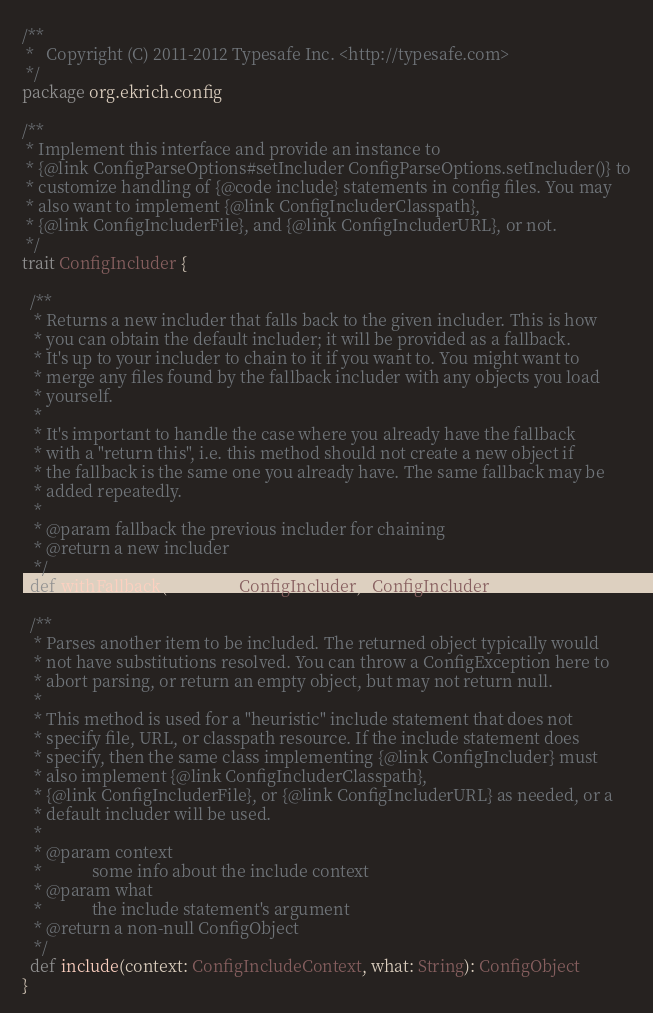<code> <loc_0><loc_0><loc_500><loc_500><_Scala_>/**
 *   Copyright (C) 2011-2012 Typesafe Inc. <http://typesafe.com>
 */
package org.ekrich.config

/**
 * Implement this interface and provide an instance to
 * {@link ConfigParseOptions#setIncluder ConfigParseOptions.setIncluder()} to
 * customize handling of {@code include} statements in config files. You may
 * also want to implement {@link ConfigIncluderClasspath},
 * {@link ConfigIncluderFile}, and {@link ConfigIncluderURL}, or not.
 */
trait ConfigIncluder {

  /**
   * Returns a new includer that falls back to the given includer. This is how
   * you can obtain the default includer; it will be provided as a fallback.
   * It's up to your includer to chain to it if you want to. You might want to
   * merge any files found by the fallback includer with any objects you load
   * yourself.
   *
   * It's important to handle the case where you already have the fallback
   * with a "return this", i.e. this method should not create a new object if
   * the fallback is the same one you already have. The same fallback may be
   * added repeatedly.
   *
   * @param fallback the previous includer for chaining
   * @return a new includer
   */
  def withFallback(fallback: ConfigIncluder): ConfigIncluder

  /**
   * Parses another item to be included. The returned object typically would
   * not have substitutions resolved. You can throw a ConfigException here to
   * abort parsing, or return an empty object, but may not return null.
   *
   * This method is used for a "heuristic" include statement that does not
   * specify file, URL, or classpath resource. If the include statement does
   * specify, then the same class implementing {@link ConfigIncluder} must
   * also implement {@link ConfigIncluderClasspath},
   * {@link ConfigIncluderFile}, or {@link ConfigIncluderURL} as needed, or a
   * default includer will be used.
   *
   * @param context
   *            some info about the include context
   * @param what
   *            the include statement's argument
   * @return a non-null ConfigObject
   */
  def include(context: ConfigIncludeContext, what: String): ConfigObject
}
</code> 